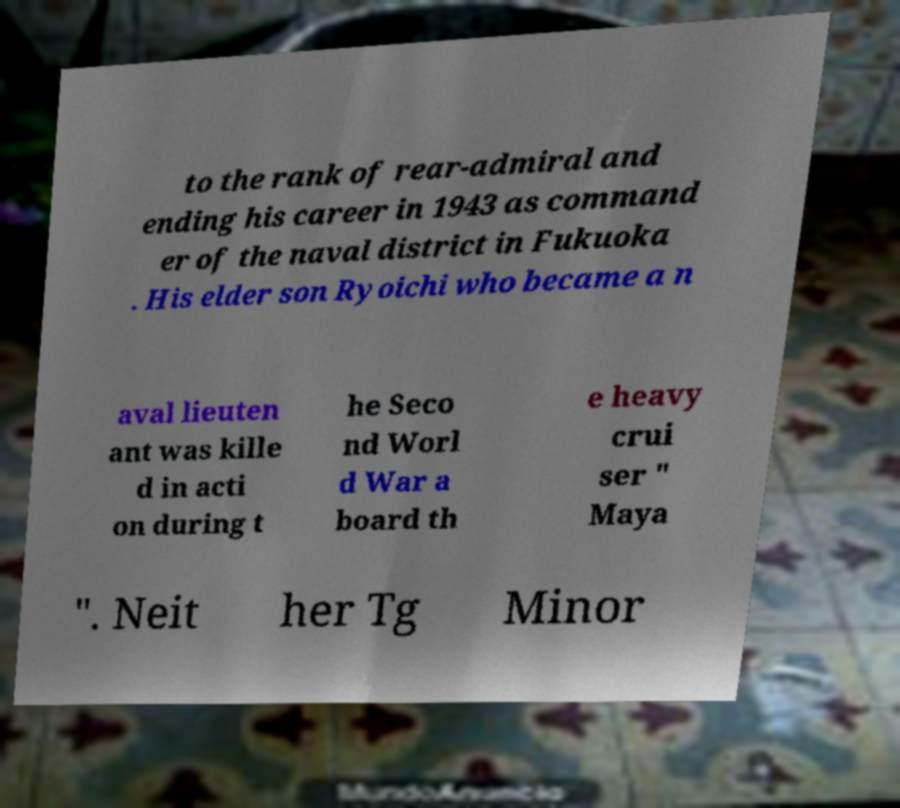Could you extract and type out the text from this image? to the rank of rear-admiral and ending his career in 1943 as command er of the naval district in Fukuoka . His elder son Ryoichi who became a n aval lieuten ant was kille d in acti on during t he Seco nd Worl d War a board th e heavy crui ser " Maya ". Neit her Tg Minor 